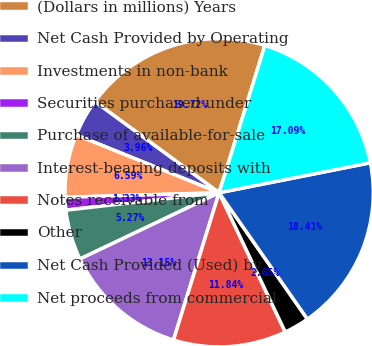Convert chart to OTSL. <chart><loc_0><loc_0><loc_500><loc_500><pie_chart><fcel>(Dollars in millions) Years<fcel>Net Cash Provided by Operating<fcel>Investments in non-bank<fcel>Securities purchased under<fcel>Purchase of available-for-sale<fcel>Interest-bearing deposits with<fcel>Notes receivable from<fcel>Other<fcel>Net Cash Provided (Used) by<fcel>Net proceeds from commercial<nl><fcel>19.72%<fcel>3.96%<fcel>6.59%<fcel>1.33%<fcel>5.27%<fcel>13.15%<fcel>11.84%<fcel>2.65%<fcel>18.41%<fcel>17.09%<nl></chart> 